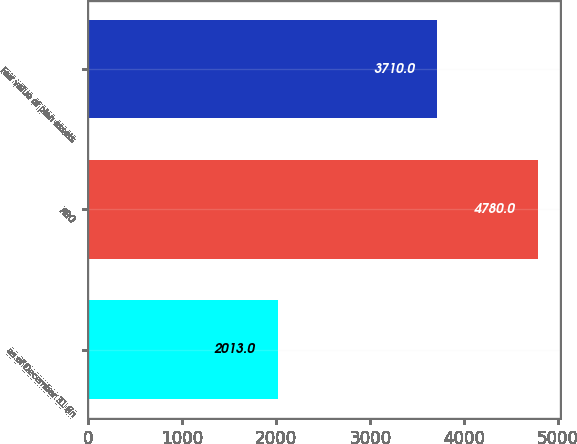<chart> <loc_0><loc_0><loc_500><loc_500><bar_chart><fcel>as of December 31 (in<fcel>ABO<fcel>Fair value of plan assets<nl><fcel>2013<fcel>4780<fcel>3710<nl></chart> 